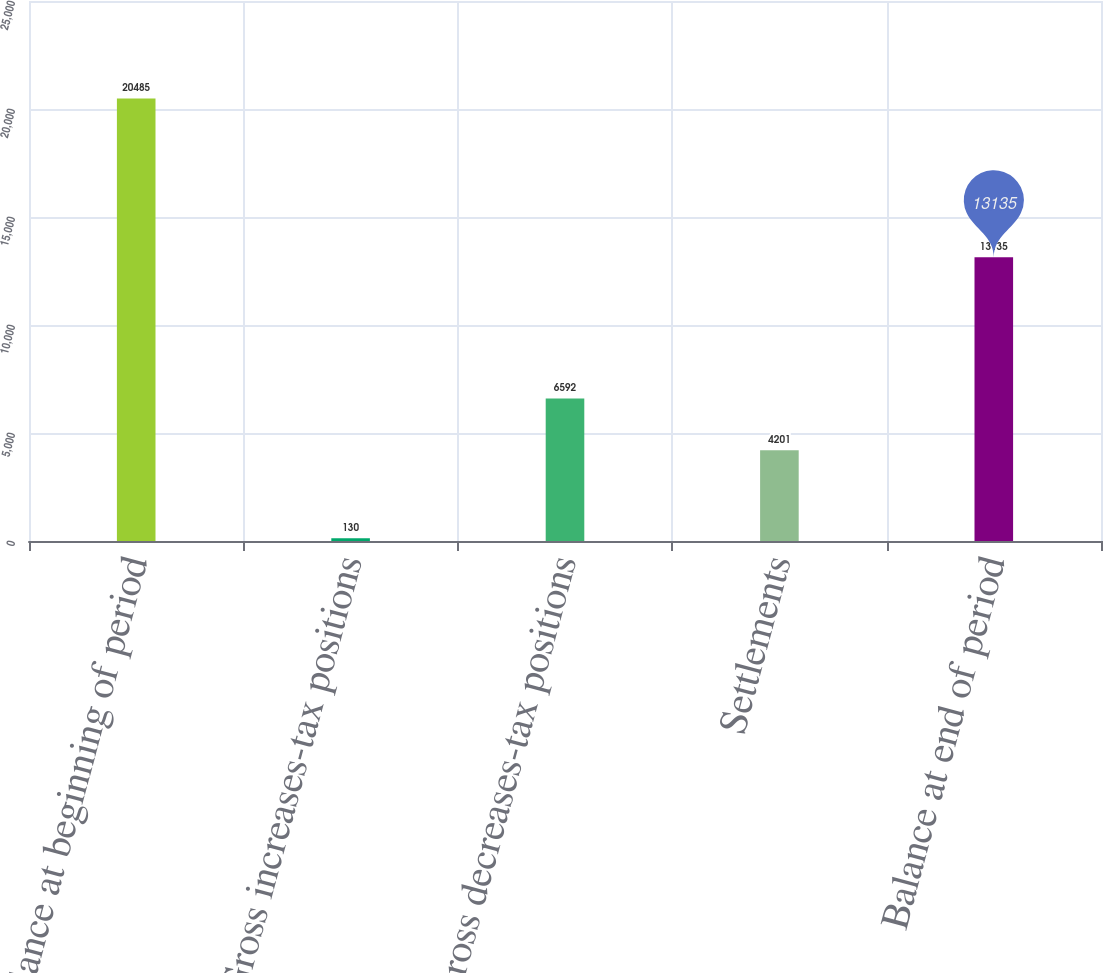Convert chart. <chart><loc_0><loc_0><loc_500><loc_500><bar_chart><fcel>Balance at beginning of period<fcel>Gross increases-tax positions<fcel>Gross decreases-tax positions<fcel>Settlements<fcel>Balance at end of period<nl><fcel>20485<fcel>130<fcel>6592<fcel>4201<fcel>13135<nl></chart> 